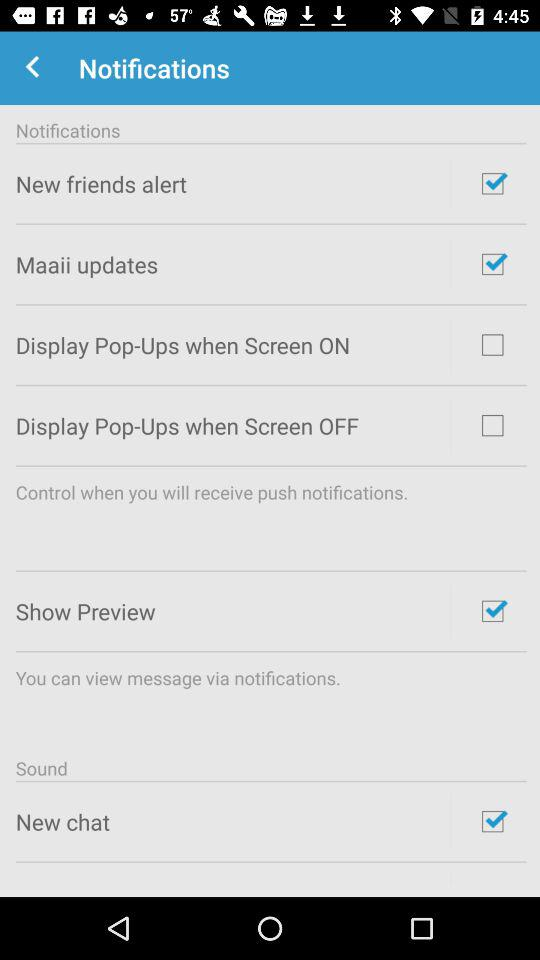What is the status of the "Maaii updates"? The status of the "Maaii updates" is "on". 